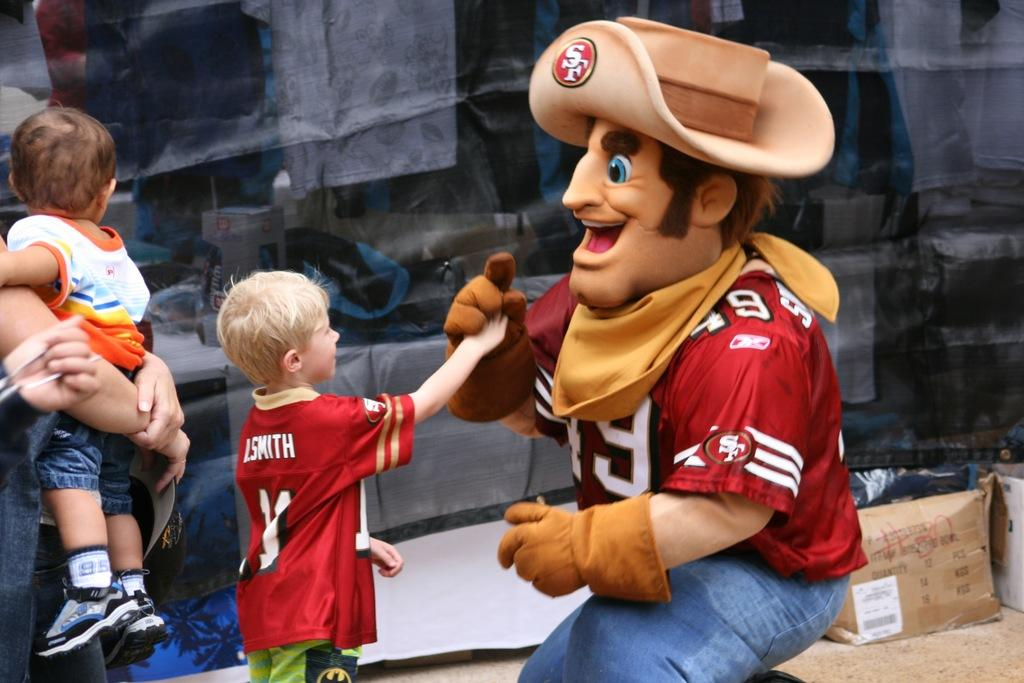<image>
Present a compact description of the photo's key features. A boy in a football shirt that says I.Smith on the back shakes hands with a cowboy. 